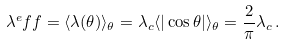<formula> <loc_0><loc_0><loc_500><loc_500>\lambda ^ { e } f f = \langle \lambda ( \theta ) \rangle _ { \theta } = \lambda _ { c } \langle | \cos \theta | \rangle _ { \theta } = \frac { 2 } { \pi } \lambda _ { c } \, .</formula> 